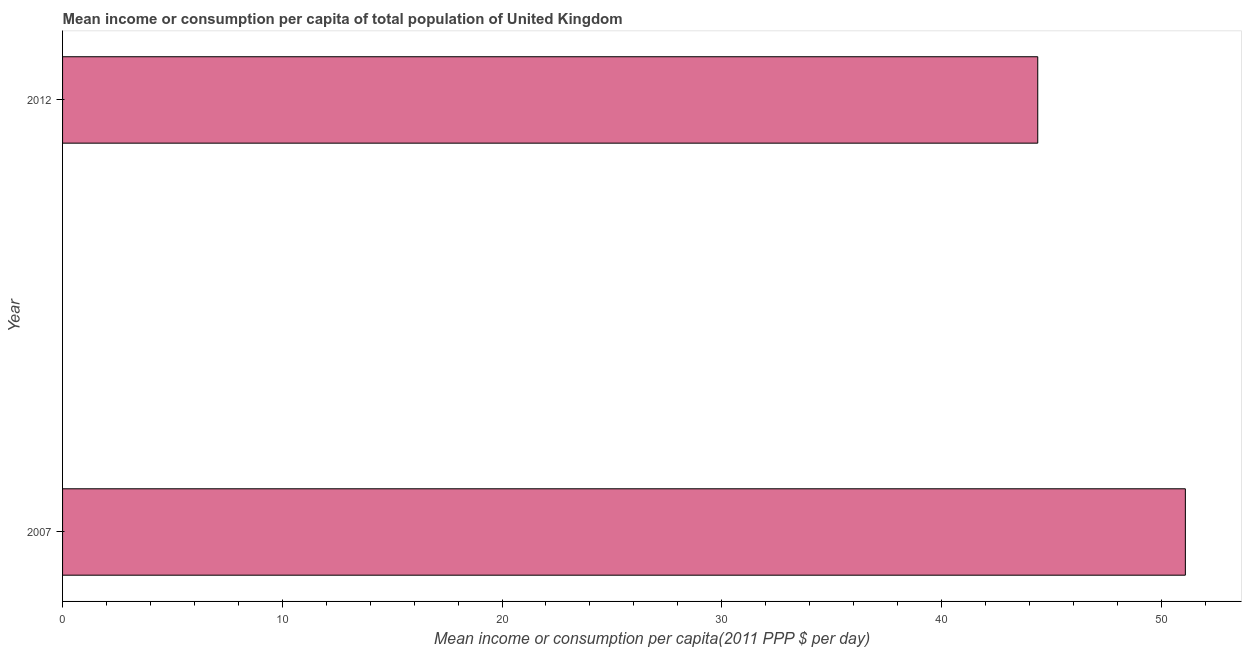Does the graph contain any zero values?
Offer a very short reply. No. What is the title of the graph?
Ensure brevity in your answer.  Mean income or consumption per capita of total population of United Kingdom. What is the label or title of the X-axis?
Offer a terse response. Mean income or consumption per capita(2011 PPP $ per day). What is the mean income or consumption in 2012?
Your response must be concise. 44.38. Across all years, what is the maximum mean income or consumption?
Your answer should be very brief. 51.1. Across all years, what is the minimum mean income or consumption?
Offer a very short reply. 44.38. In which year was the mean income or consumption minimum?
Provide a short and direct response. 2012. What is the sum of the mean income or consumption?
Your answer should be very brief. 95.49. What is the difference between the mean income or consumption in 2007 and 2012?
Ensure brevity in your answer.  6.72. What is the average mean income or consumption per year?
Keep it short and to the point. 47.74. What is the median mean income or consumption?
Ensure brevity in your answer.  47.74. Do a majority of the years between 2007 and 2012 (inclusive) have mean income or consumption greater than 34 $?
Your answer should be compact. Yes. What is the ratio of the mean income or consumption in 2007 to that in 2012?
Make the answer very short. 1.15. In how many years, is the mean income or consumption greater than the average mean income or consumption taken over all years?
Offer a terse response. 1. Are all the bars in the graph horizontal?
Give a very brief answer. Yes. What is the difference between two consecutive major ticks on the X-axis?
Ensure brevity in your answer.  10. Are the values on the major ticks of X-axis written in scientific E-notation?
Your answer should be very brief. No. What is the Mean income or consumption per capita(2011 PPP $ per day) in 2007?
Provide a short and direct response. 51.1. What is the Mean income or consumption per capita(2011 PPP $ per day) of 2012?
Keep it short and to the point. 44.38. What is the difference between the Mean income or consumption per capita(2011 PPP $ per day) in 2007 and 2012?
Ensure brevity in your answer.  6.72. What is the ratio of the Mean income or consumption per capita(2011 PPP $ per day) in 2007 to that in 2012?
Provide a short and direct response. 1.15. 